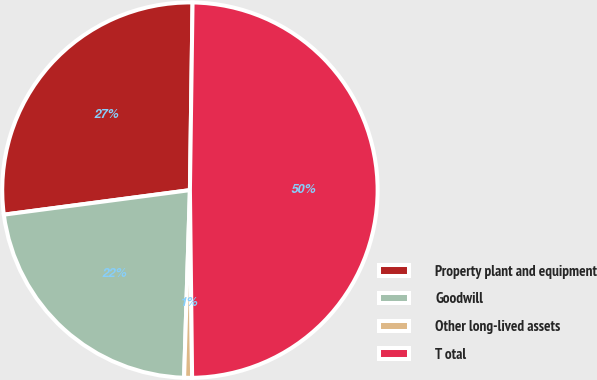Convert chart to OTSL. <chart><loc_0><loc_0><loc_500><loc_500><pie_chart><fcel>Property plant and equipment<fcel>Goodwill<fcel>Other long-lived assets<fcel>T otal<nl><fcel>27.31%<fcel>22.42%<fcel>0.68%<fcel>49.59%<nl></chart> 